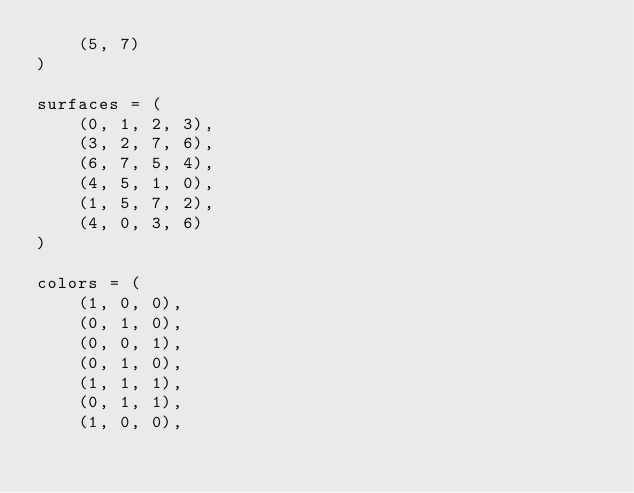<code> <loc_0><loc_0><loc_500><loc_500><_Python_>    (5, 7)
)

surfaces = (
    (0, 1, 2, 3),
    (3, 2, 7, 6),
    (6, 7, 5, 4),
    (4, 5, 1, 0),
    (1, 5, 7, 2),
    (4, 0, 3, 6)
)

colors = (
    (1, 0, 0),
    (0, 1, 0),
    (0, 0, 1),
    (0, 1, 0),
    (1, 1, 1),
    (0, 1, 1),
    (1, 0, 0),</code> 